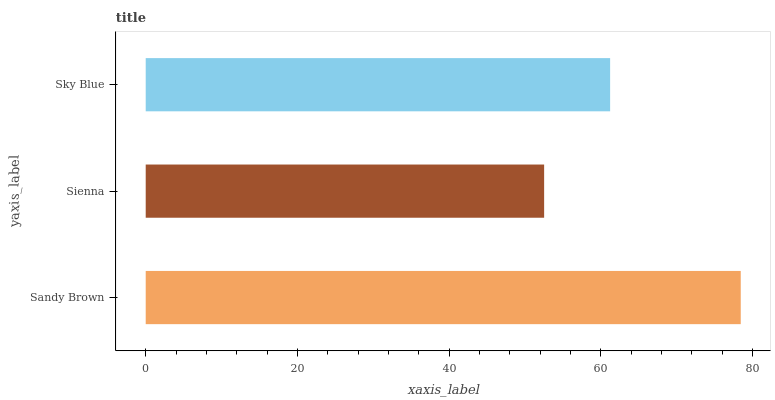Is Sienna the minimum?
Answer yes or no. Yes. Is Sandy Brown the maximum?
Answer yes or no. Yes. Is Sky Blue the minimum?
Answer yes or no. No. Is Sky Blue the maximum?
Answer yes or no. No. Is Sky Blue greater than Sienna?
Answer yes or no. Yes. Is Sienna less than Sky Blue?
Answer yes or no. Yes. Is Sienna greater than Sky Blue?
Answer yes or no. No. Is Sky Blue less than Sienna?
Answer yes or no. No. Is Sky Blue the high median?
Answer yes or no. Yes. Is Sky Blue the low median?
Answer yes or no. Yes. Is Sienna the high median?
Answer yes or no. No. Is Sienna the low median?
Answer yes or no. No. 